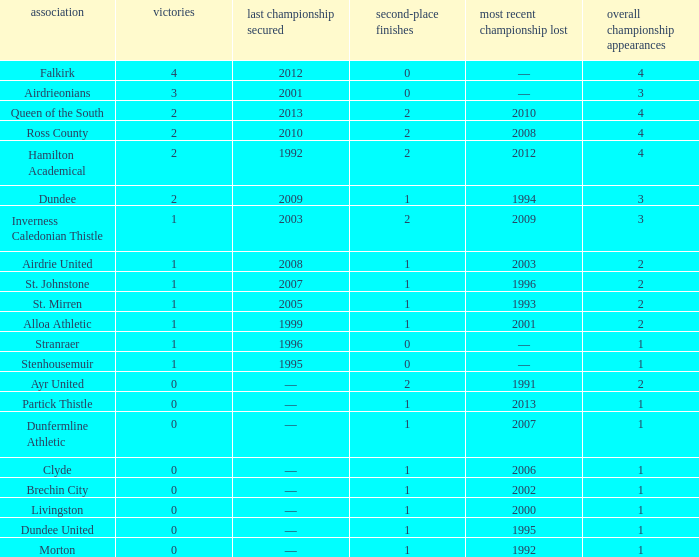What club has over 1 runners-up and last won the final in 2010? Ross County. 